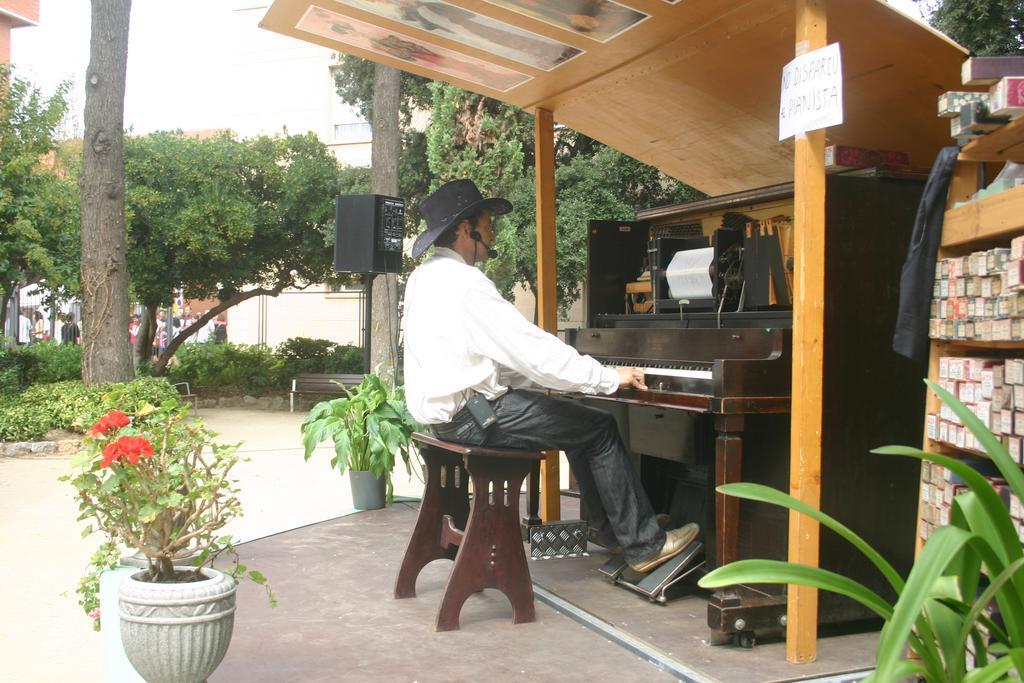Could you give a brief overview of what you see in this image? In the image on the left side there is a pot with plant. There is a man with a hat and mic is sitting on the wooden stool in front of him there is a piano. He is sitting under the wooden roof and also there are poles with paper. On the right corner of the image there is a cupboard with many items in it. And also there are leaves. In the background there are trees, small plants and also there is a bench. Behind the trees there are people and also there are buildings. 